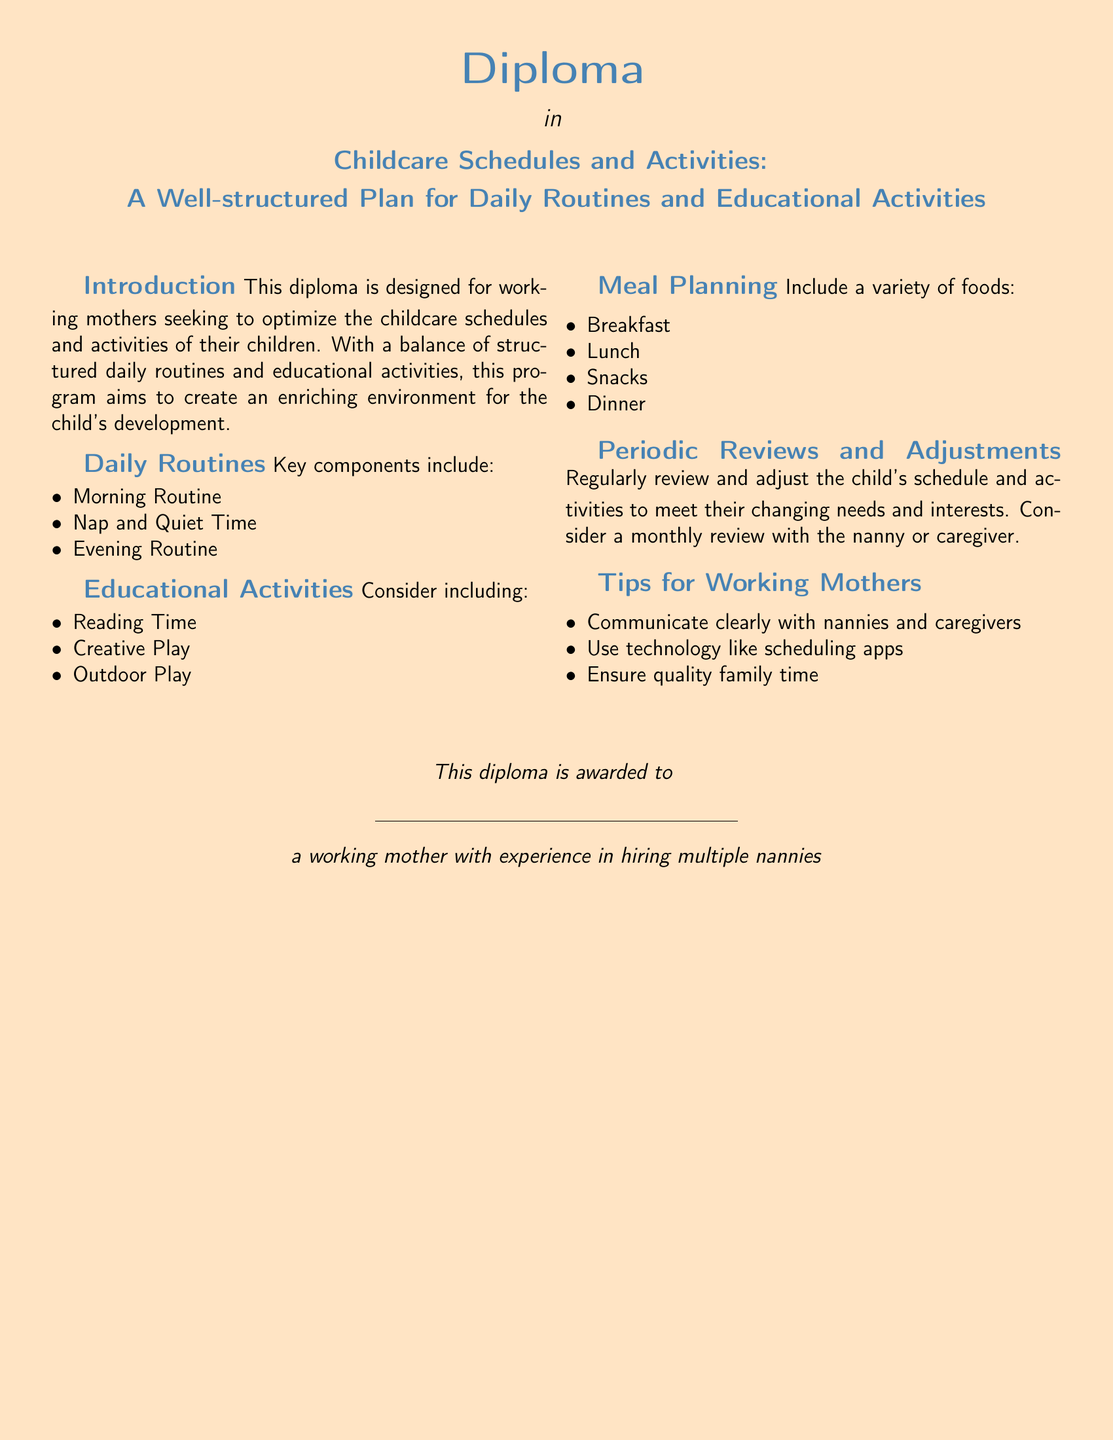What is the diploma awarded in? The diploma is awarded in the subject of childcare schedules and activities.
Answer: Childcare Schedules and Activities What are the key components of daily routines? The document lists key components of daily routines including morning routine, nap and quiet time, and evening routine.
Answer: Morning Routine, Nap and Quiet Time, Evening Routine List one type of educational activity suggested. The document suggests including educational activities such as reading time, creative play, or outdoor play.
Answer: Reading Time How often should the child's schedule be reviewed? The diploma suggests that the child's schedule should be reviewed regularly, specifically mentioning a monthly review.
Answer: Monthly What is one tip for working mothers provided in the document? The document provides tips for working mothers, one of which is to communicate clearly with nannies and caregivers.
Answer: Communicate clearly with nannies and caregivers What format of document is this? The document is a diploma designed specifically for working mothers.
Answer: Diploma What type of food categories are included in meal planning? The meal planning section includes categories like breakfast, lunch, snacks, and dinner.
Answer: Breakfast, Lunch, Snacks, Dinner 